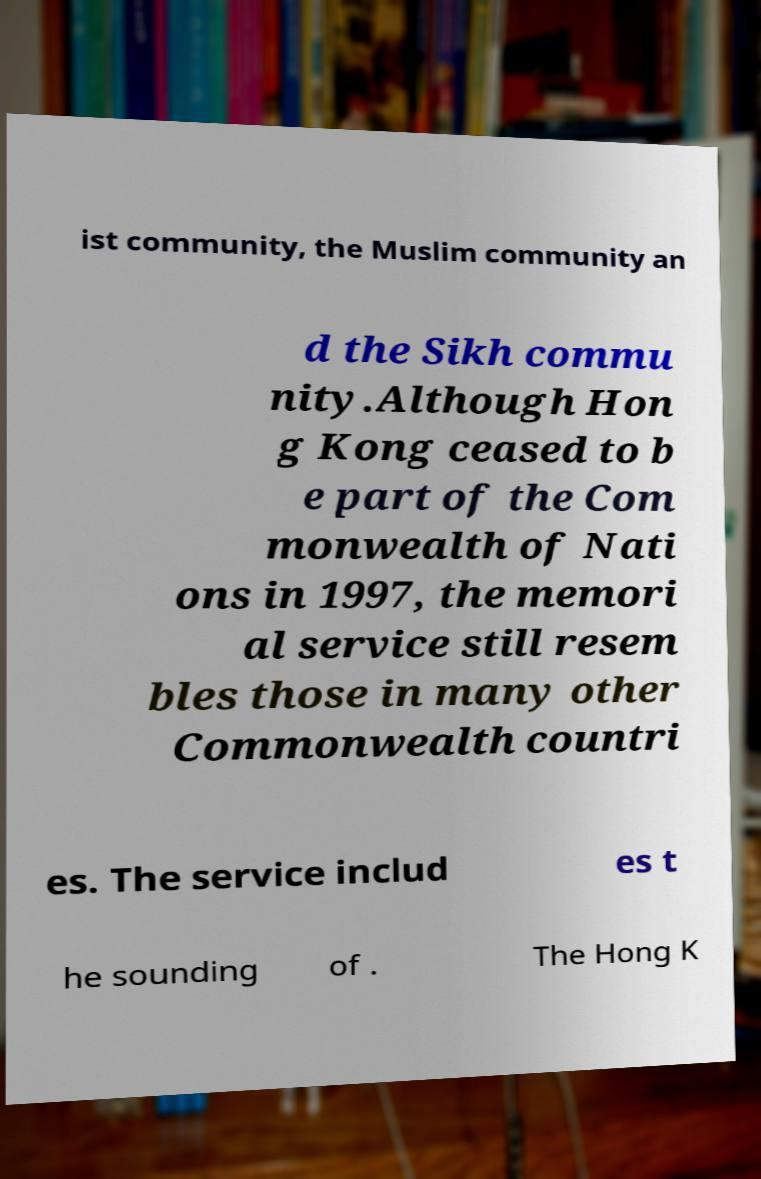Could you extract and type out the text from this image? ist community, the Muslim community an d the Sikh commu nity.Although Hon g Kong ceased to b e part of the Com monwealth of Nati ons in 1997, the memori al service still resem bles those in many other Commonwealth countri es. The service includ es t he sounding of . The Hong K 